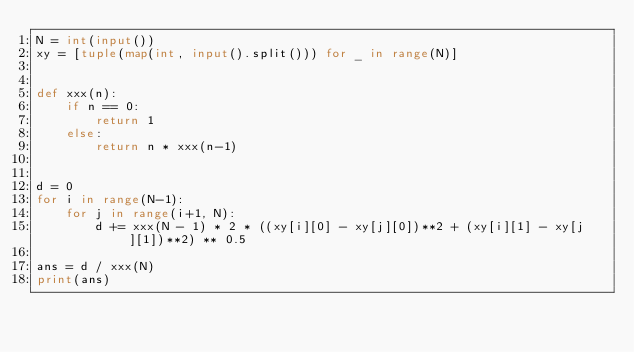<code> <loc_0><loc_0><loc_500><loc_500><_Python_>N = int(input())
xy = [tuple(map(int, input().split())) for _ in range(N)]


def xxx(n):
    if n == 0:
        return 1
    else:
        return n * xxx(n-1)


d = 0
for i in range(N-1):
    for j in range(i+1, N):
        d += xxx(N - 1) * 2 * ((xy[i][0] - xy[j][0])**2 + (xy[i][1] - xy[j][1])**2) ** 0.5

ans = d / xxx(N)
print(ans)</code> 